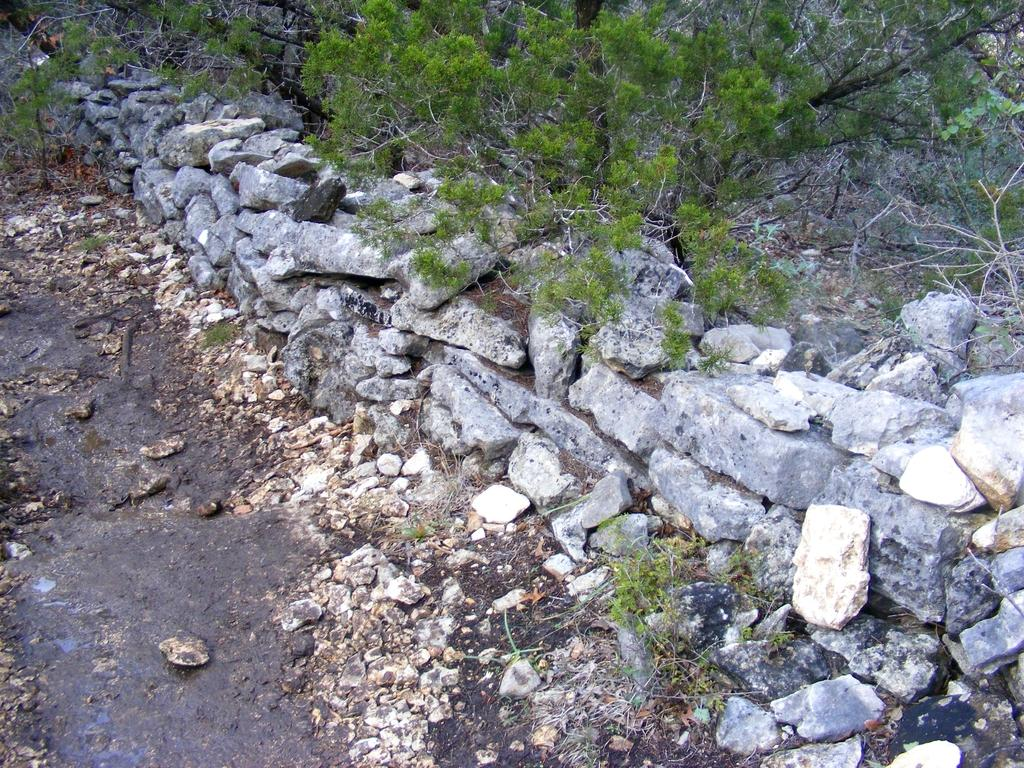What type of natural elements can be seen in the image? There are stones and plants in the image. Can you describe the stones in the image? The stones are visible in the image, but no specific details about their size, shape, or color are provided. What type of plants are present in the image? The plants in the image are not described in detail, so it is not possible to identify their species or characteristics. What color is the toothbrush in the image? There is no toothbrush present in the image. How many vans are visible in the image? There are no vans visible in the image. 